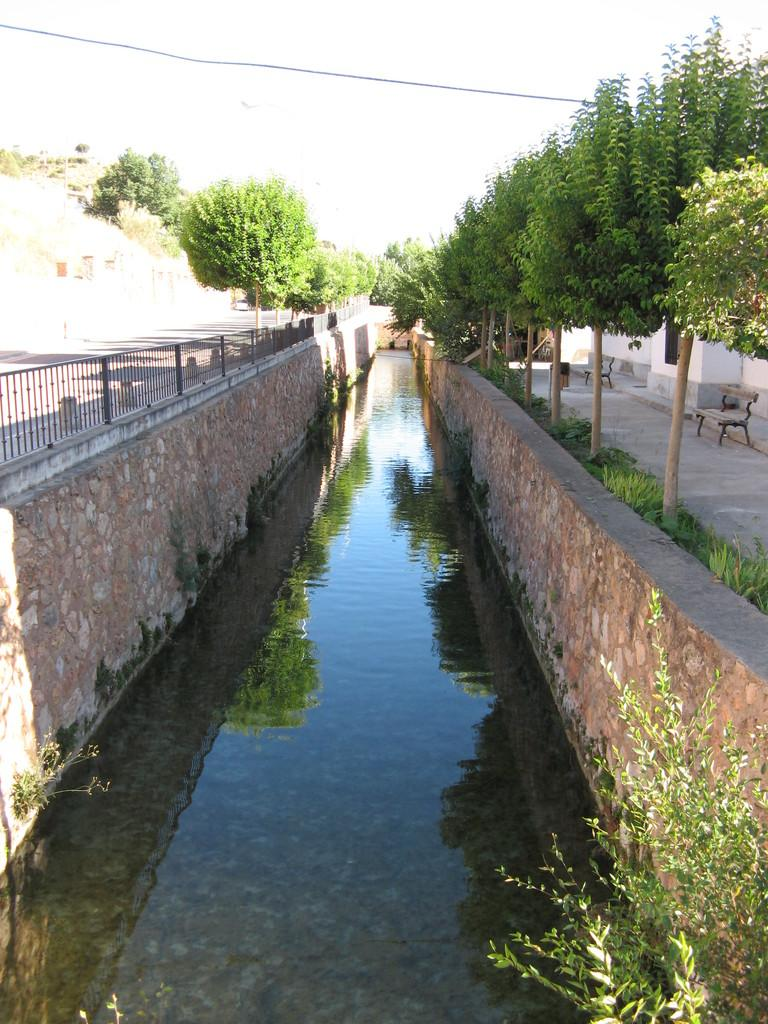What type of infrastructure is present in the image? There is a drainage in the image. What type of seating is available on the road in the image? There is a bench on the road in the image. What type of structure can be seen in the image? There is a building in the image. What type of vegetation is present in the image? There are plants in the image. Can you tell me how many pickles are on the bench in the image? There are no pickles present in the image; it features a bench, a building, plants, and a drainage. What type of railway is visible in the image? There is no railway present in the image. 